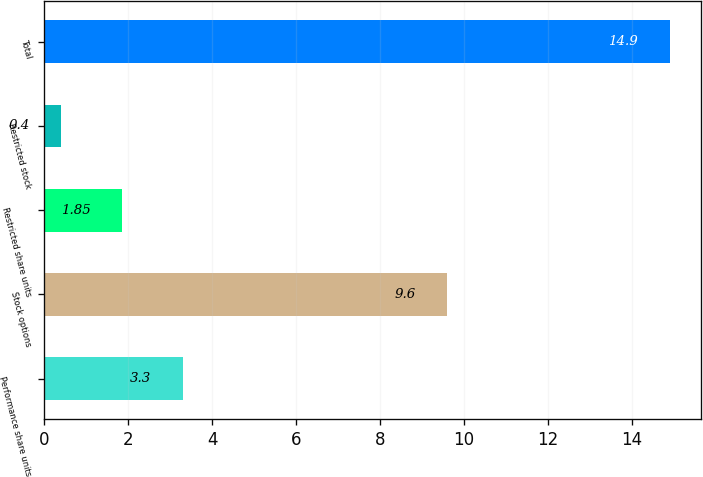<chart> <loc_0><loc_0><loc_500><loc_500><bar_chart><fcel>Performance share units<fcel>Stock options<fcel>Restricted share units<fcel>Restricted stock<fcel>Total<nl><fcel>3.3<fcel>9.6<fcel>1.85<fcel>0.4<fcel>14.9<nl></chart> 